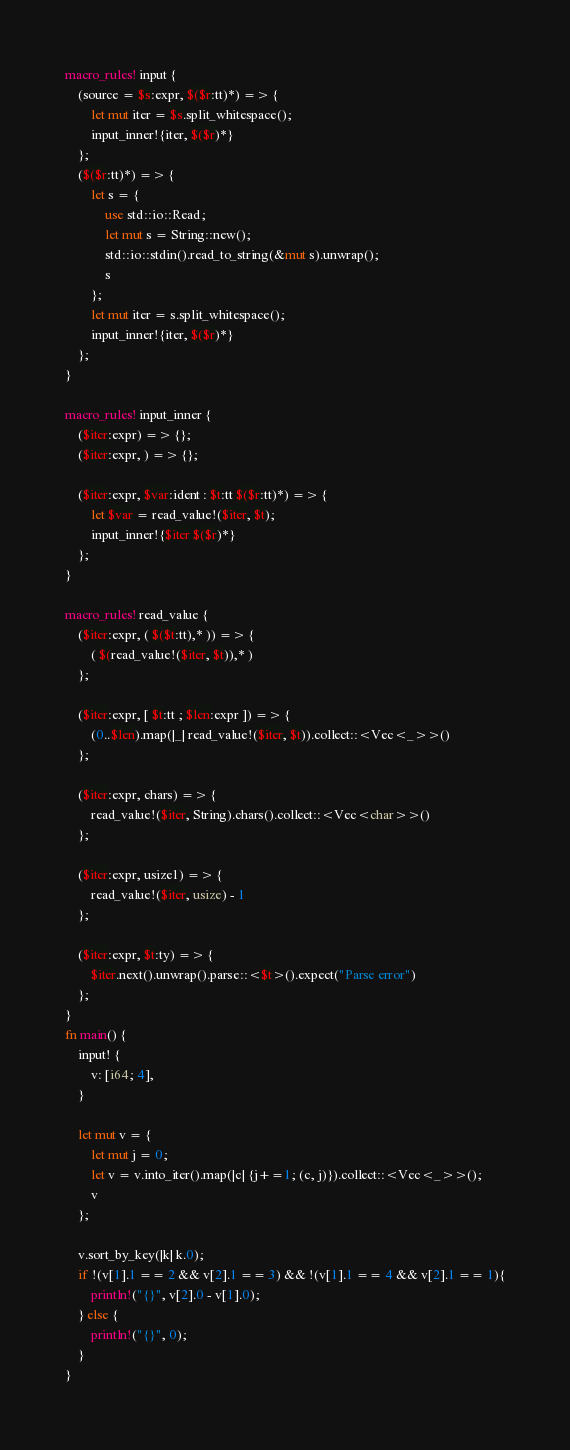<code> <loc_0><loc_0><loc_500><loc_500><_Rust_>macro_rules! input {
    (source = $s:expr, $($r:tt)*) => {
        let mut iter = $s.split_whitespace();
        input_inner!{iter, $($r)*}
    };
    ($($r:tt)*) => {
        let s = {
            use std::io::Read;
            let mut s = String::new();
            std::io::stdin().read_to_string(&mut s).unwrap();
            s
        };
        let mut iter = s.split_whitespace();
        input_inner!{iter, $($r)*}
    };
}

macro_rules! input_inner {
    ($iter:expr) => {};
    ($iter:expr, ) => {};

    ($iter:expr, $var:ident : $t:tt $($r:tt)*) => {
        let $var = read_value!($iter, $t);
        input_inner!{$iter $($r)*}
    };
}

macro_rules! read_value {
    ($iter:expr, ( $($t:tt),* )) => {
        ( $(read_value!($iter, $t)),* )
    };

    ($iter:expr, [ $t:tt ; $len:expr ]) => {
        (0..$len).map(|_| read_value!($iter, $t)).collect::<Vec<_>>()
    };

    ($iter:expr, chars) => {
        read_value!($iter, String).chars().collect::<Vec<char>>()
    };

    ($iter:expr, usize1) => {
        read_value!($iter, usize) - 1
    };

    ($iter:expr, $t:ty) => {
        $iter.next().unwrap().parse::<$t>().expect("Parse error")
    };
}
fn main() {
    input! {
        v: [i64; 4],
    }

    let mut v = {
        let mut j = 0;
        let v = v.into_iter().map(|c| {j+=1; (c, j)}).collect::<Vec<_>>();
        v
    };

    v.sort_by_key(|k| k.0);
    if !(v[1].1 == 2 && v[2].1 == 3) && !(v[1].1 == 4 && v[2].1 == 1){
        println!("{}", v[2].0 - v[1].0);
    } else {
        println!("{}", 0);
    }
}</code> 